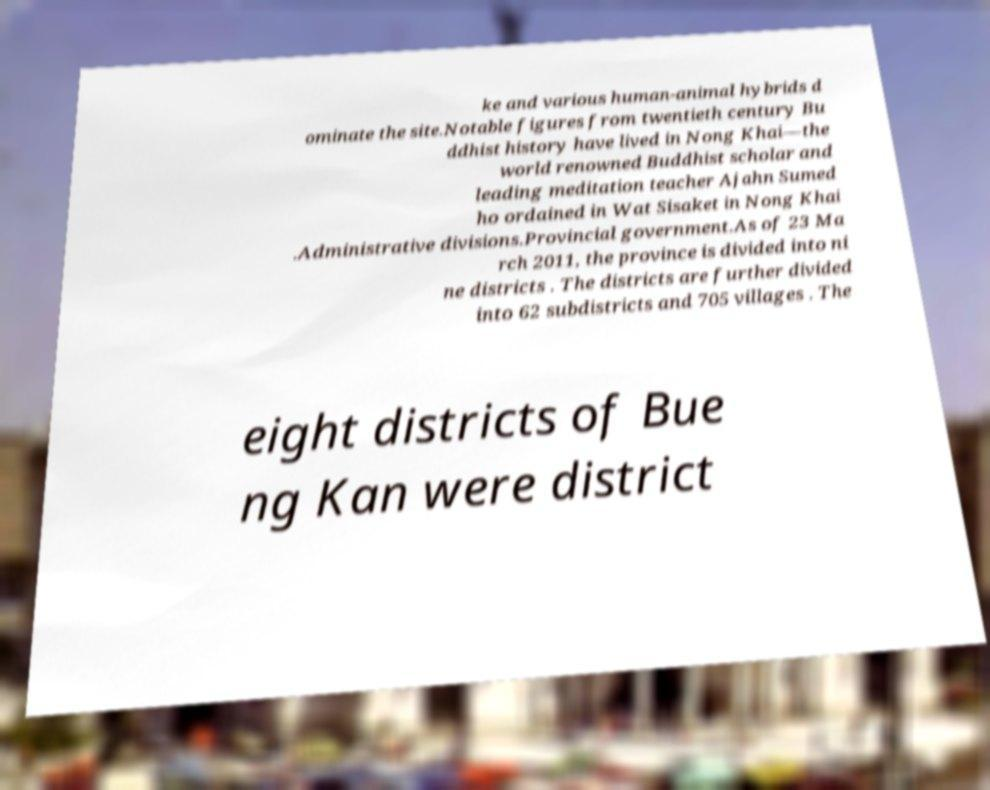Can you accurately transcribe the text from the provided image for me? ke and various human-animal hybrids d ominate the site.Notable figures from twentieth century Bu ddhist history have lived in Nong Khai—the world renowned Buddhist scholar and leading meditation teacher Ajahn Sumed ho ordained in Wat Sisaket in Nong Khai .Administrative divisions.Provincial government.As of 23 Ma rch 2011, the province is divided into ni ne districts . The districts are further divided into 62 subdistricts and 705 villages . The eight districts of Bue ng Kan were district 